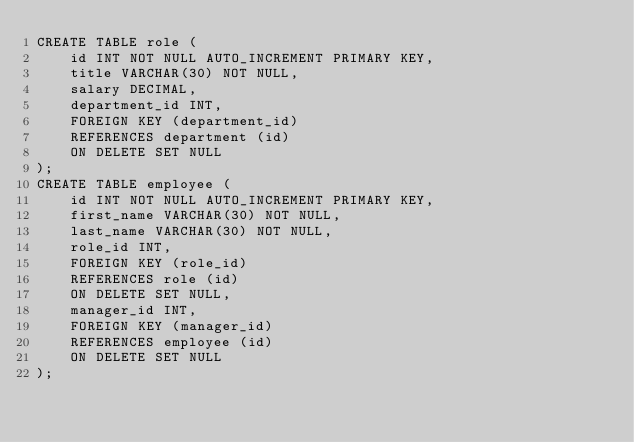Convert code to text. <code><loc_0><loc_0><loc_500><loc_500><_SQL_>CREATE TABLE role (
    id INT NOT NULL AUTO_INCREMENT PRIMARY KEY,
    title VARCHAR(30) NOT NULL,
    salary DECIMAL,
    department_id INT,
    FOREIGN KEY (department_id)
	REFERENCES department (id)
	ON DELETE SET NULL
);
CREATE TABLE employee (
    id INT NOT NULL AUTO_INCREMENT PRIMARY KEY,
    first_name VARCHAR(30) NOT NULL,
    last_name VARCHAR(30) NOT NULL,
    role_id INT,
    FOREIGN KEY (role_id)
	REFERENCES role (id)
	ON DELETE SET NULL,
    manager_id INT,
    FOREIGN KEY (manager_id)
	REFERENCES employee (id)
	ON DELETE SET NULL
);
</code> 